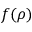<formula> <loc_0><loc_0><loc_500><loc_500>f ( \rho )</formula> 